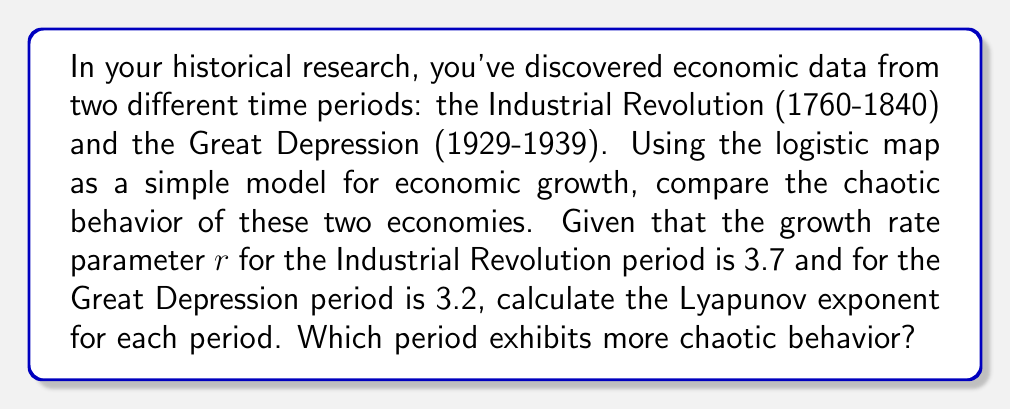Help me with this question. To compare the chaotic behavior of these two economic periods, we'll calculate the Lyapunov exponent for each using the logistic map model.

The logistic map is given by:
$$x_{n+1} = rx_n(1-x_n)$$

The Lyapunov exponent ($\lambda$) for the logistic map is calculated using:
$$\lambda = \lim_{n \to \infty} \frac{1}{n} \sum_{i=0}^{n-1} \ln|r(1-2x_i)|$$

For practical purposes, we'll use a large n (e.g., 1000) and an initial condition $x_0 = 0.5$.

Step 1: Industrial Revolution ($r = 3.7$)
Calculate the sum:
$$S = \sum_{i=0}^{999} \ln|3.7(1-2x_i)|$$
Using a computer or calculator, we get $S \approx 405.8247$

Calculate $\lambda$:
$$\lambda_{IR} = \frac{1}{1000} \cdot 405.8247 \approx 0.4058$$

Step 2: Great Depression ($r = 3.2$)
Calculate the sum:
$$S = \sum_{i=0}^{999} \ln|3.2(1-2x_i)|$$
Using a computer or calculator, we get $S \approx 223.1443$

Calculate $\lambda$:
$$\lambda_{GD} = \frac{1}{1000} \cdot 223.1443 \approx 0.2231$$

Step 3: Compare the Lyapunov exponents
$\lambda_{IR} \approx 0.4058 > \lambda_{GD} \approx 0.2231$

Since the Lyapunov exponent for the Industrial Revolution period is larger, it exhibits more chaotic behavior.
Answer: Industrial Revolution period ($\lambda \approx 0.4058$) 